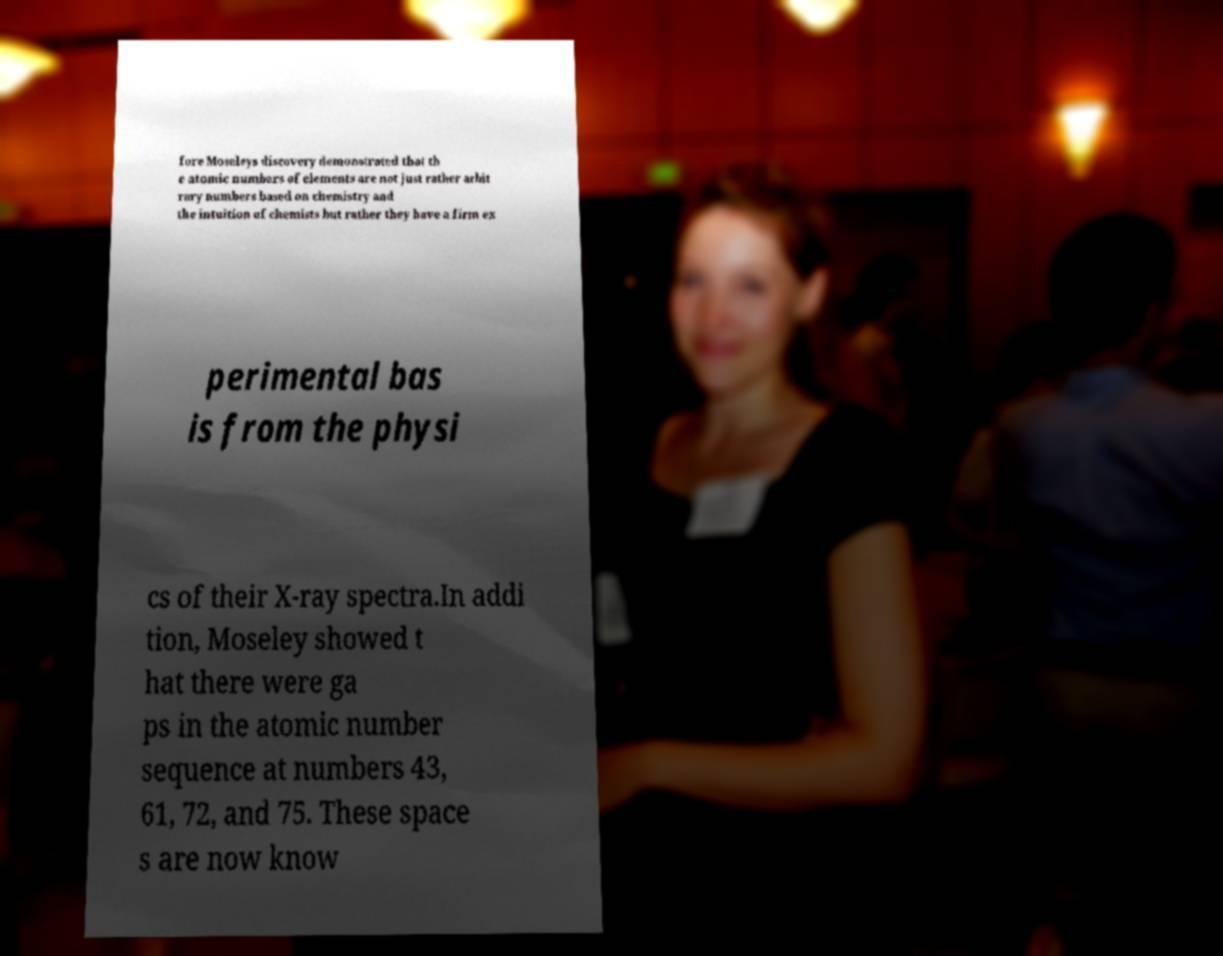I need the written content from this picture converted into text. Can you do that? fore Moseleys discovery demonstrated that th e atomic numbers of elements are not just rather arbit rary numbers based on chemistry and the intuition of chemists but rather they have a firm ex perimental bas is from the physi cs of their X-ray spectra.In addi tion, Moseley showed t hat there were ga ps in the atomic number sequence at numbers 43, 61, 72, and 75. These space s are now know 